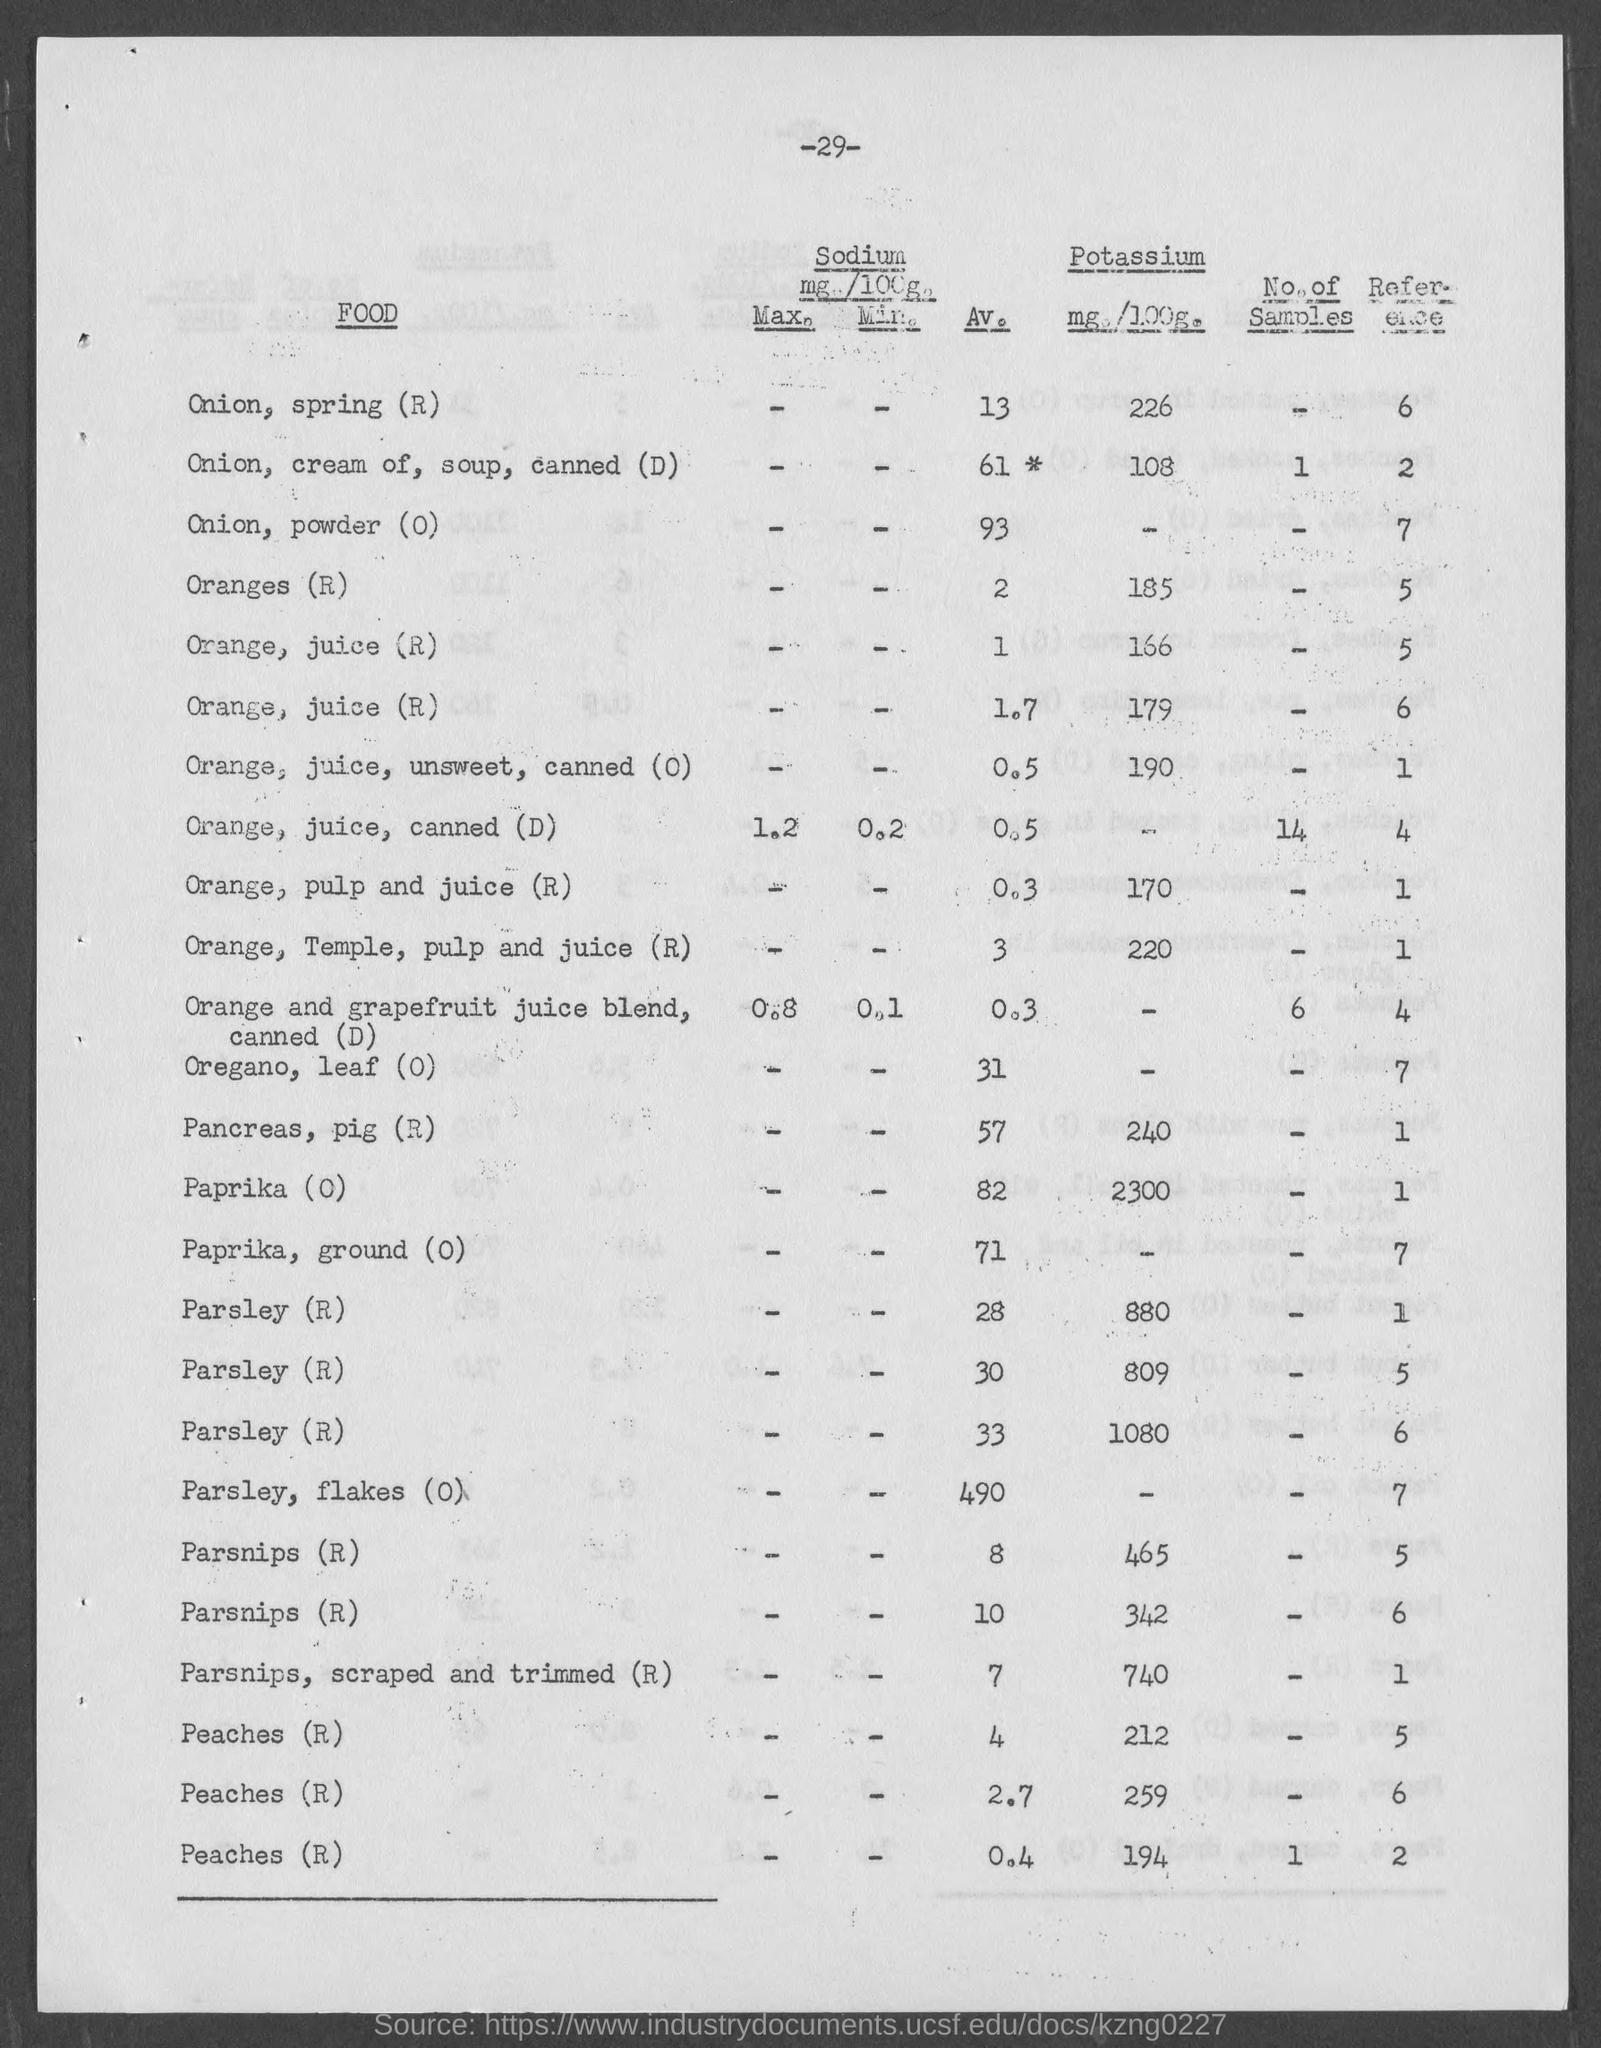Mention a couple of crucial points in this snapshot. The average value of pancreas, pig(R) as mentioned in the given page is 57. The average value of sodium present in an onion, specifically in Spring brand as mentioned on the given page is 13. The maximum amount of sodium present in orange juice from cans is 1.2 grams per 100 grams according to the given page. The value of potassium present in paprika (O) is 2300 as mentioned in the given form. The value of potassium present in an onion, specifically a spring onion (R), is 226, as mentioned on the given page. 